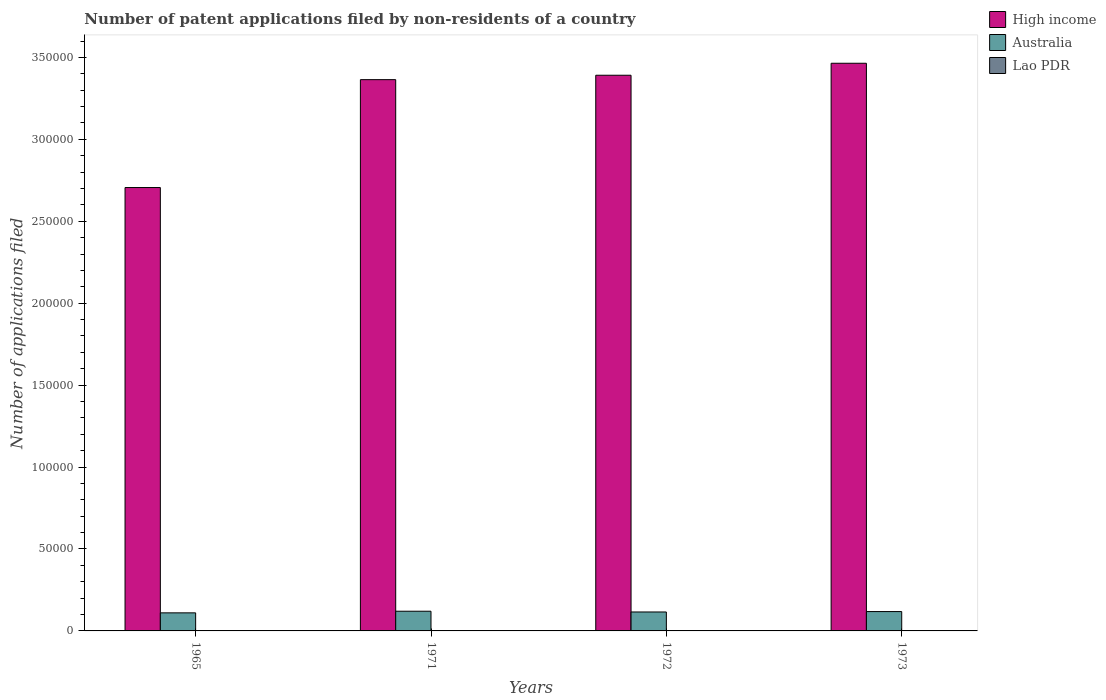Are the number of bars per tick equal to the number of legend labels?
Keep it short and to the point. Yes. Are the number of bars on each tick of the X-axis equal?
Make the answer very short. Yes. How many bars are there on the 4th tick from the left?
Keep it short and to the point. 3. How many bars are there on the 1st tick from the right?
Make the answer very short. 3. What is the label of the 1st group of bars from the left?
Offer a terse response. 1965. In how many cases, is the number of bars for a given year not equal to the number of legend labels?
Provide a short and direct response. 0. What is the number of applications filed in High income in 1973?
Your answer should be very brief. 3.46e+05. Across all years, what is the maximum number of applications filed in High income?
Your response must be concise. 3.46e+05. In which year was the number of applications filed in Lao PDR maximum?
Your answer should be very brief. 1965. In which year was the number of applications filed in Australia minimum?
Provide a short and direct response. 1965. What is the total number of applications filed in Australia in the graph?
Provide a short and direct response. 4.64e+04. What is the difference between the number of applications filed in High income in 1971 and that in 1972?
Your response must be concise. -2684. What is the difference between the number of applications filed in Lao PDR in 1972 and the number of applications filed in High income in 1971?
Keep it short and to the point. -3.36e+05. What is the average number of applications filed in Lao PDR per year?
Your response must be concise. 11.5. In the year 1971, what is the difference between the number of applications filed in High income and number of applications filed in Australia?
Provide a succinct answer. 3.24e+05. What is the ratio of the number of applications filed in Lao PDR in 1965 to that in 1971?
Your answer should be very brief. 2.75. Is the number of applications filed in Lao PDR in 1965 less than that in 1973?
Your response must be concise. No. Is the difference between the number of applications filed in High income in 1971 and 1972 greater than the difference between the number of applications filed in Australia in 1971 and 1972?
Provide a short and direct response. No. What is the difference between the highest and the second highest number of applications filed in High income?
Give a very brief answer. 7315. What is the difference between the highest and the lowest number of applications filed in Australia?
Your answer should be compact. 989. What does the 2nd bar from the left in 1972 represents?
Your answer should be compact. Australia. What does the 1st bar from the right in 1973 represents?
Provide a succinct answer. Lao PDR. How many years are there in the graph?
Keep it short and to the point. 4. What is the difference between two consecutive major ticks on the Y-axis?
Keep it short and to the point. 5.00e+04. Are the values on the major ticks of Y-axis written in scientific E-notation?
Offer a very short reply. No. Does the graph contain any zero values?
Offer a very short reply. No. Does the graph contain grids?
Keep it short and to the point. No. Where does the legend appear in the graph?
Your response must be concise. Top right. How many legend labels are there?
Keep it short and to the point. 3. What is the title of the graph?
Your answer should be compact. Number of patent applications filed by non-residents of a country. What is the label or title of the Y-axis?
Provide a short and direct response. Number of applications filed. What is the Number of applications filed in High income in 1965?
Ensure brevity in your answer.  2.71e+05. What is the Number of applications filed of Australia in 1965?
Provide a short and direct response. 1.10e+04. What is the Number of applications filed of Lao PDR in 1965?
Your response must be concise. 22. What is the Number of applications filed in High income in 1971?
Offer a very short reply. 3.36e+05. What is the Number of applications filed of Australia in 1971?
Give a very brief answer. 1.20e+04. What is the Number of applications filed in High income in 1972?
Provide a short and direct response. 3.39e+05. What is the Number of applications filed of Australia in 1972?
Your response must be concise. 1.16e+04. What is the Number of applications filed of Lao PDR in 1972?
Offer a very short reply. 12. What is the Number of applications filed in High income in 1973?
Your response must be concise. 3.46e+05. What is the Number of applications filed in Australia in 1973?
Your response must be concise. 1.18e+04. What is the Number of applications filed of Lao PDR in 1973?
Your answer should be compact. 4. Across all years, what is the maximum Number of applications filed in High income?
Provide a succinct answer. 3.46e+05. Across all years, what is the maximum Number of applications filed of Australia?
Your answer should be compact. 1.20e+04. Across all years, what is the minimum Number of applications filed of High income?
Ensure brevity in your answer.  2.71e+05. Across all years, what is the minimum Number of applications filed in Australia?
Provide a short and direct response. 1.10e+04. Across all years, what is the minimum Number of applications filed in Lao PDR?
Provide a succinct answer. 4. What is the total Number of applications filed in High income in the graph?
Provide a succinct answer. 1.29e+06. What is the total Number of applications filed in Australia in the graph?
Give a very brief answer. 4.64e+04. What is the difference between the Number of applications filed in High income in 1965 and that in 1971?
Your answer should be compact. -6.58e+04. What is the difference between the Number of applications filed of Australia in 1965 and that in 1971?
Give a very brief answer. -989. What is the difference between the Number of applications filed of High income in 1965 and that in 1972?
Offer a terse response. -6.85e+04. What is the difference between the Number of applications filed of Australia in 1965 and that in 1972?
Offer a very short reply. -532. What is the difference between the Number of applications filed in Lao PDR in 1965 and that in 1972?
Make the answer very short. 10. What is the difference between the Number of applications filed of High income in 1965 and that in 1973?
Your response must be concise. -7.58e+04. What is the difference between the Number of applications filed of Australia in 1965 and that in 1973?
Offer a terse response. -782. What is the difference between the Number of applications filed in Lao PDR in 1965 and that in 1973?
Offer a terse response. 18. What is the difference between the Number of applications filed in High income in 1971 and that in 1972?
Your answer should be very brief. -2684. What is the difference between the Number of applications filed of Australia in 1971 and that in 1972?
Ensure brevity in your answer.  457. What is the difference between the Number of applications filed in High income in 1971 and that in 1973?
Make the answer very short. -9999. What is the difference between the Number of applications filed of Australia in 1971 and that in 1973?
Keep it short and to the point. 207. What is the difference between the Number of applications filed in Lao PDR in 1971 and that in 1973?
Offer a very short reply. 4. What is the difference between the Number of applications filed of High income in 1972 and that in 1973?
Offer a terse response. -7315. What is the difference between the Number of applications filed in Australia in 1972 and that in 1973?
Ensure brevity in your answer.  -250. What is the difference between the Number of applications filed in High income in 1965 and the Number of applications filed in Australia in 1971?
Provide a short and direct response. 2.59e+05. What is the difference between the Number of applications filed of High income in 1965 and the Number of applications filed of Lao PDR in 1971?
Your response must be concise. 2.71e+05. What is the difference between the Number of applications filed in Australia in 1965 and the Number of applications filed in Lao PDR in 1971?
Provide a succinct answer. 1.10e+04. What is the difference between the Number of applications filed of High income in 1965 and the Number of applications filed of Australia in 1972?
Your answer should be very brief. 2.59e+05. What is the difference between the Number of applications filed in High income in 1965 and the Number of applications filed in Lao PDR in 1972?
Provide a succinct answer. 2.71e+05. What is the difference between the Number of applications filed in Australia in 1965 and the Number of applications filed in Lao PDR in 1972?
Give a very brief answer. 1.10e+04. What is the difference between the Number of applications filed of High income in 1965 and the Number of applications filed of Australia in 1973?
Give a very brief answer. 2.59e+05. What is the difference between the Number of applications filed of High income in 1965 and the Number of applications filed of Lao PDR in 1973?
Provide a succinct answer. 2.71e+05. What is the difference between the Number of applications filed in Australia in 1965 and the Number of applications filed in Lao PDR in 1973?
Your answer should be very brief. 1.10e+04. What is the difference between the Number of applications filed in High income in 1971 and the Number of applications filed in Australia in 1972?
Keep it short and to the point. 3.25e+05. What is the difference between the Number of applications filed in High income in 1971 and the Number of applications filed in Lao PDR in 1972?
Your answer should be very brief. 3.36e+05. What is the difference between the Number of applications filed in Australia in 1971 and the Number of applications filed in Lao PDR in 1972?
Your answer should be compact. 1.20e+04. What is the difference between the Number of applications filed in High income in 1971 and the Number of applications filed in Australia in 1973?
Provide a succinct answer. 3.25e+05. What is the difference between the Number of applications filed in High income in 1971 and the Number of applications filed in Lao PDR in 1973?
Provide a succinct answer. 3.36e+05. What is the difference between the Number of applications filed of Australia in 1971 and the Number of applications filed of Lao PDR in 1973?
Your answer should be compact. 1.20e+04. What is the difference between the Number of applications filed of High income in 1972 and the Number of applications filed of Australia in 1973?
Provide a succinct answer. 3.27e+05. What is the difference between the Number of applications filed in High income in 1972 and the Number of applications filed in Lao PDR in 1973?
Keep it short and to the point. 3.39e+05. What is the difference between the Number of applications filed of Australia in 1972 and the Number of applications filed of Lao PDR in 1973?
Provide a succinct answer. 1.16e+04. What is the average Number of applications filed of High income per year?
Provide a short and direct response. 3.23e+05. What is the average Number of applications filed of Australia per year?
Provide a short and direct response. 1.16e+04. What is the average Number of applications filed of Lao PDR per year?
Make the answer very short. 11.5. In the year 1965, what is the difference between the Number of applications filed in High income and Number of applications filed in Australia?
Offer a very short reply. 2.60e+05. In the year 1965, what is the difference between the Number of applications filed in High income and Number of applications filed in Lao PDR?
Keep it short and to the point. 2.71e+05. In the year 1965, what is the difference between the Number of applications filed of Australia and Number of applications filed of Lao PDR?
Provide a short and direct response. 1.10e+04. In the year 1971, what is the difference between the Number of applications filed in High income and Number of applications filed in Australia?
Your answer should be compact. 3.24e+05. In the year 1971, what is the difference between the Number of applications filed of High income and Number of applications filed of Lao PDR?
Provide a short and direct response. 3.36e+05. In the year 1971, what is the difference between the Number of applications filed of Australia and Number of applications filed of Lao PDR?
Offer a terse response. 1.20e+04. In the year 1972, what is the difference between the Number of applications filed in High income and Number of applications filed in Australia?
Keep it short and to the point. 3.28e+05. In the year 1972, what is the difference between the Number of applications filed in High income and Number of applications filed in Lao PDR?
Ensure brevity in your answer.  3.39e+05. In the year 1972, what is the difference between the Number of applications filed in Australia and Number of applications filed in Lao PDR?
Your answer should be very brief. 1.15e+04. In the year 1973, what is the difference between the Number of applications filed in High income and Number of applications filed in Australia?
Offer a terse response. 3.35e+05. In the year 1973, what is the difference between the Number of applications filed of High income and Number of applications filed of Lao PDR?
Offer a very short reply. 3.46e+05. In the year 1973, what is the difference between the Number of applications filed of Australia and Number of applications filed of Lao PDR?
Offer a terse response. 1.18e+04. What is the ratio of the Number of applications filed of High income in 1965 to that in 1971?
Provide a short and direct response. 0.8. What is the ratio of the Number of applications filed in Australia in 1965 to that in 1971?
Provide a succinct answer. 0.92. What is the ratio of the Number of applications filed of Lao PDR in 1965 to that in 1971?
Offer a terse response. 2.75. What is the ratio of the Number of applications filed in High income in 1965 to that in 1972?
Your response must be concise. 0.8. What is the ratio of the Number of applications filed in Australia in 1965 to that in 1972?
Provide a succinct answer. 0.95. What is the ratio of the Number of applications filed of Lao PDR in 1965 to that in 1972?
Keep it short and to the point. 1.83. What is the ratio of the Number of applications filed in High income in 1965 to that in 1973?
Offer a very short reply. 0.78. What is the ratio of the Number of applications filed of Australia in 1965 to that in 1973?
Your response must be concise. 0.93. What is the ratio of the Number of applications filed in Australia in 1971 to that in 1972?
Your answer should be compact. 1.04. What is the ratio of the Number of applications filed in High income in 1971 to that in 1973?
Provide a short and direct response. 0.97. What is the ratio of the Number of applications filed of Australia in 1971 to that in 1973?
Offer a very short reply. 1.02. What is the ratio of the Number of applications filed of Lao PDR in 1971 to that in 1973?
Your answer should be compact. 2. What is the ratio of the Number of applications filed of High income in 1972 to that in 1973?
Your answer should be very brief. 0.98. What is the ratio of the Number of applications filed in Australia in 1972 to that in 1973?
Make the answer very short. 0.98. What is the difference between the highest and the second highest Number of applications filed of High income?
Your answer should be compact. 7315. What is the difference between the highest and the second highest Number of applications filed in Australia?
Ensure brevity in your answer.  207. What is the difference between the highest and the second highest Number of applications filed in Lao PDR?
Your answer should be compact. 10. What is the difference between the highest and the lowest Number of applications filed in High income?
Provide a succinct answer. 7.58e+04. What is the difference between the highest and the lowest Number of applications filed in Australia?
Offer a very short reply. 989. 